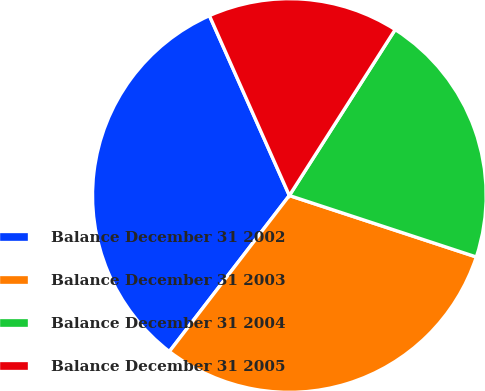Convert chart. <chart><loc_0><loc_0><loc_500><loc_500><pie_chart><fcel>Balance December 31 2002<fcel>Balance December 31 2003<fcel>Balance December 31 2004<fcel>Balance December 31 2005<nl><fcel>32.91%<fcel>30.38%<fcel>21.02%<fcel>15.69%<nl></chart> 